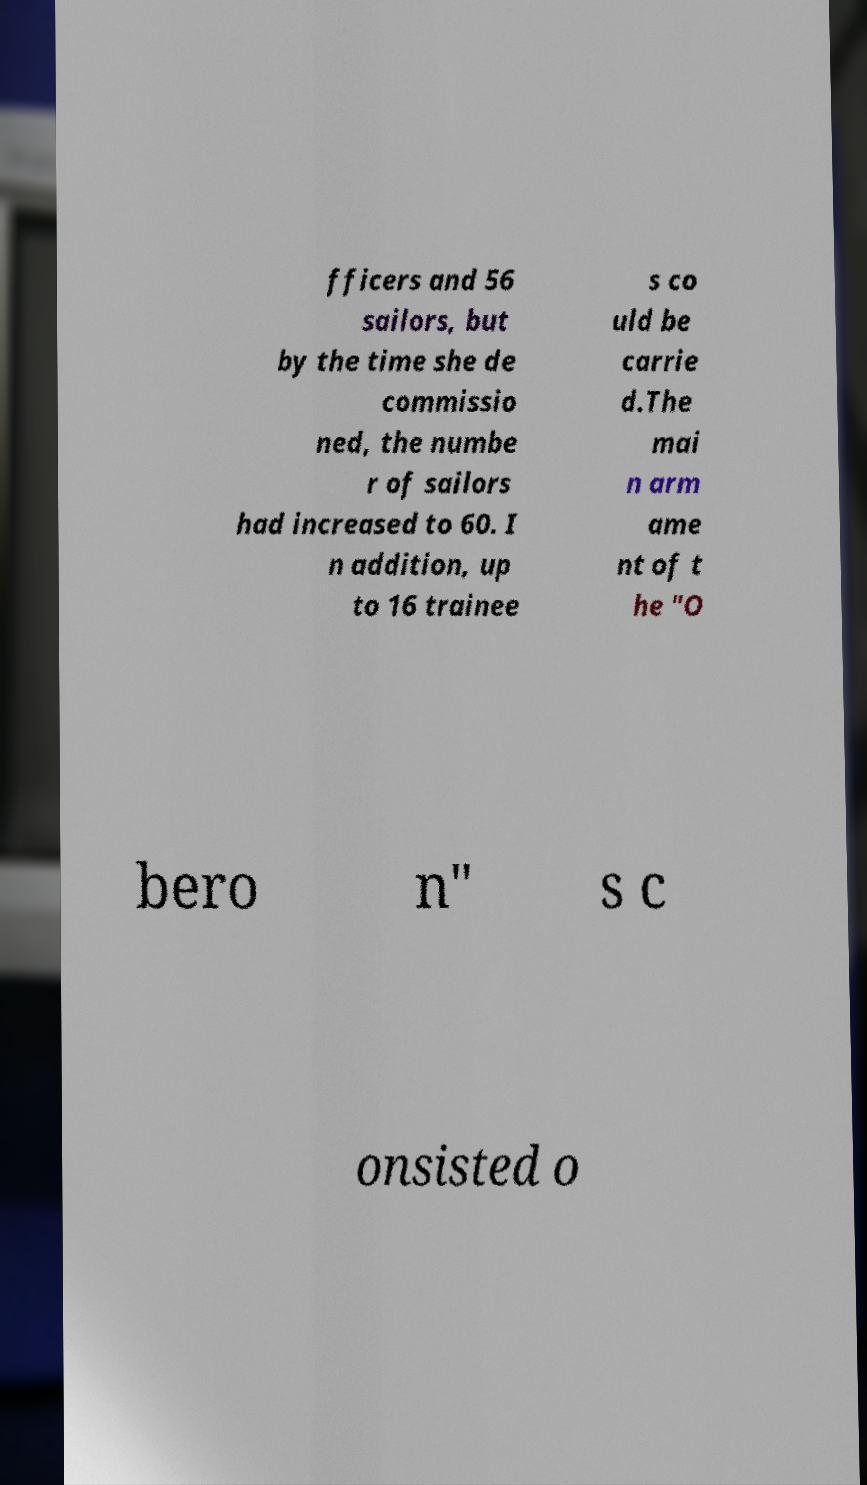Please identify and transcribe the text found in this image. fficers and 56 sailors, but by the time she de commissio ned, the numbe r of sailors had increased to 60. I n addition, up to 16 trainee s co uld be carrie d.The mai n arm ame nt of t he "O bero n" s c onsisted o 